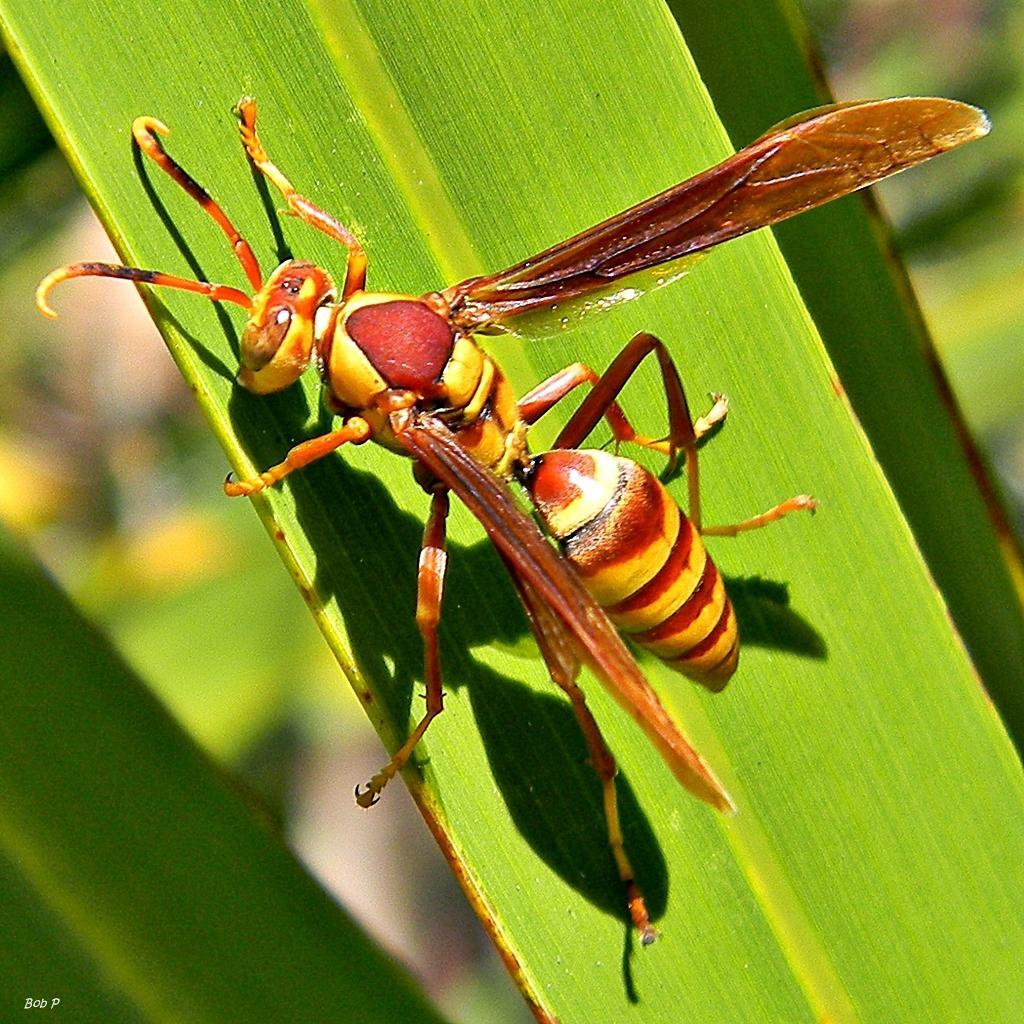Describe this image in one or two sentences. In this picture there is a brown color flying ant sitting on the green leaf. Behind there is a blur background. 